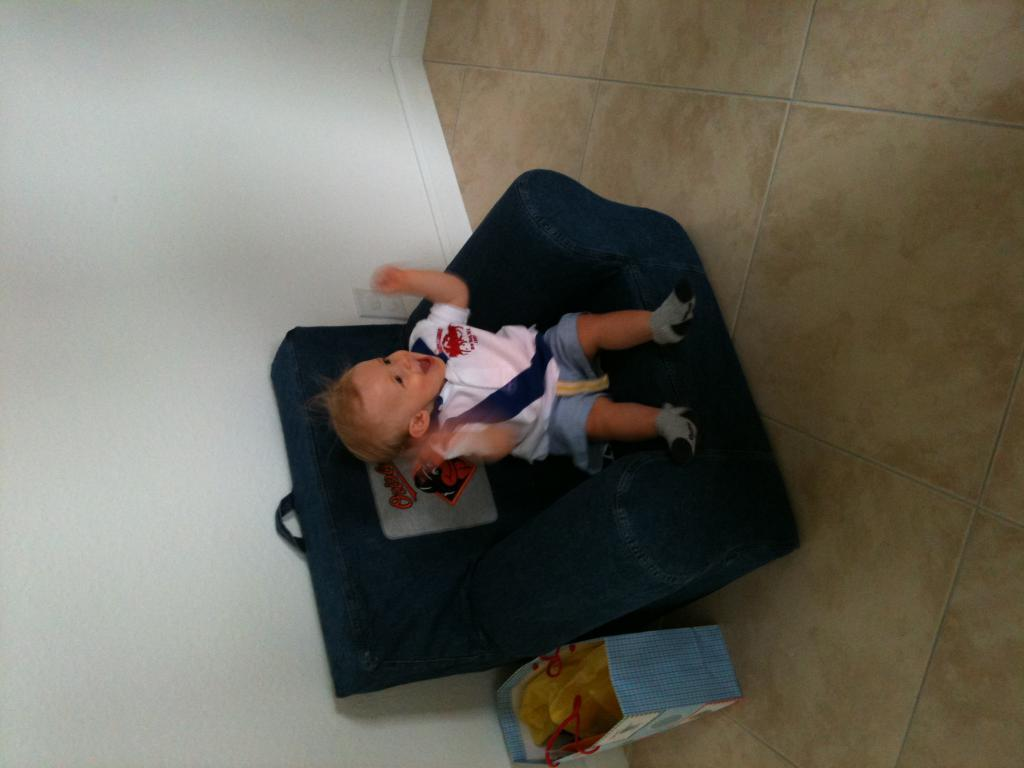What is the main subject of the picture? The main subject of the picture is a small baby. Where is the baby located in the image? The baby is on a chair. What else can be seen beside the chair in the image? There is a bag beside the chair. What type of rose is the baby holding in the image? There is no rose present in the image; the baby is not holding anything. 